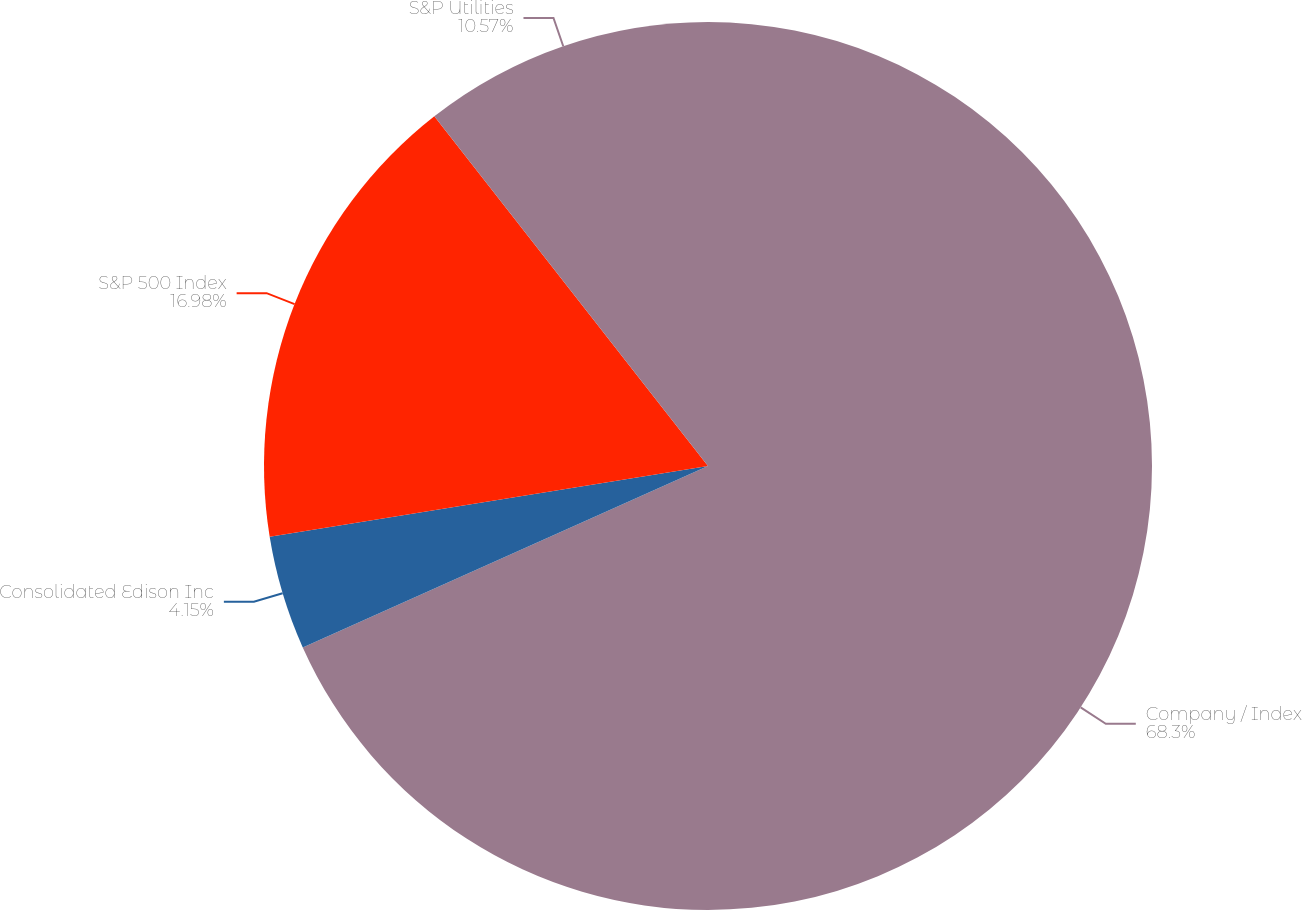Convert chart to OTSL. <chart><loc_0><loc_0><loc_500><loc_500><pie_chart><fcel>Company / Index<fcel>Consolidated Edison Inc<fcel>S&P 500 Index<fcel>S&P Utilities<nl><fcel>68.3%<fcel>4.15%<fcel>16.98%<fcel>10.57%<nl></chart> 